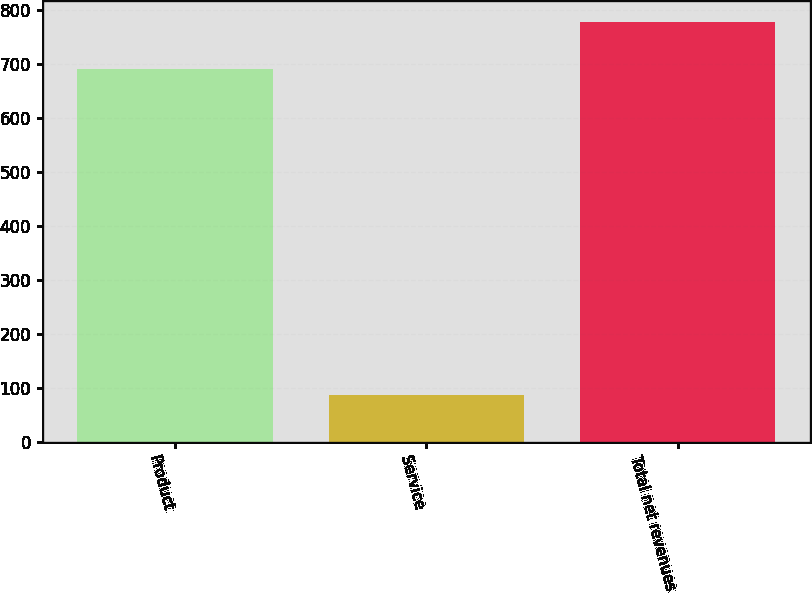Convert chart to OTSL. <chart><loc_0><loc_0><loc_500><loc_500><bar_chart><fcel>Product<fcel>Service<fcel>Total net revenues<nl><fcel>690.7<fcel>86.7<fcel>777.4<nl></chart> 